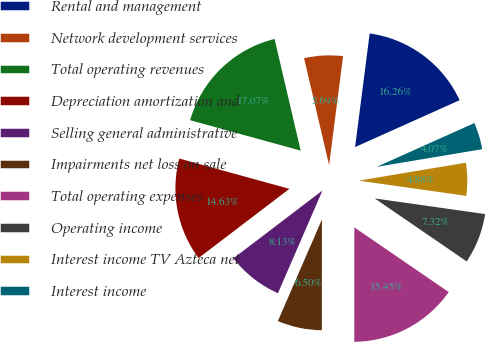<chart> <loc_0><loc_0><loc_500><loc_500><pie_chart><fcel>Rental and management<fcel>Network development services<fcel>Total operating revenues<fcel>Depreciation amortization and<fcel>Selling general administrative<fcel>Impairments net loss on sale<fcel>Total operating expenses<fcel>Operating income<fcel>Interest income TV Azteca net<fcel>Interest income<nl><fcel>16.26%<fcel>5.69%<fcel>17.07%<fcel>14.63%<fcel>8.13%<fcel>6.5%<fcel>15.45%<fcel>7.32%<fcel>4.88%<fcel>4.07%<nl></chart> 